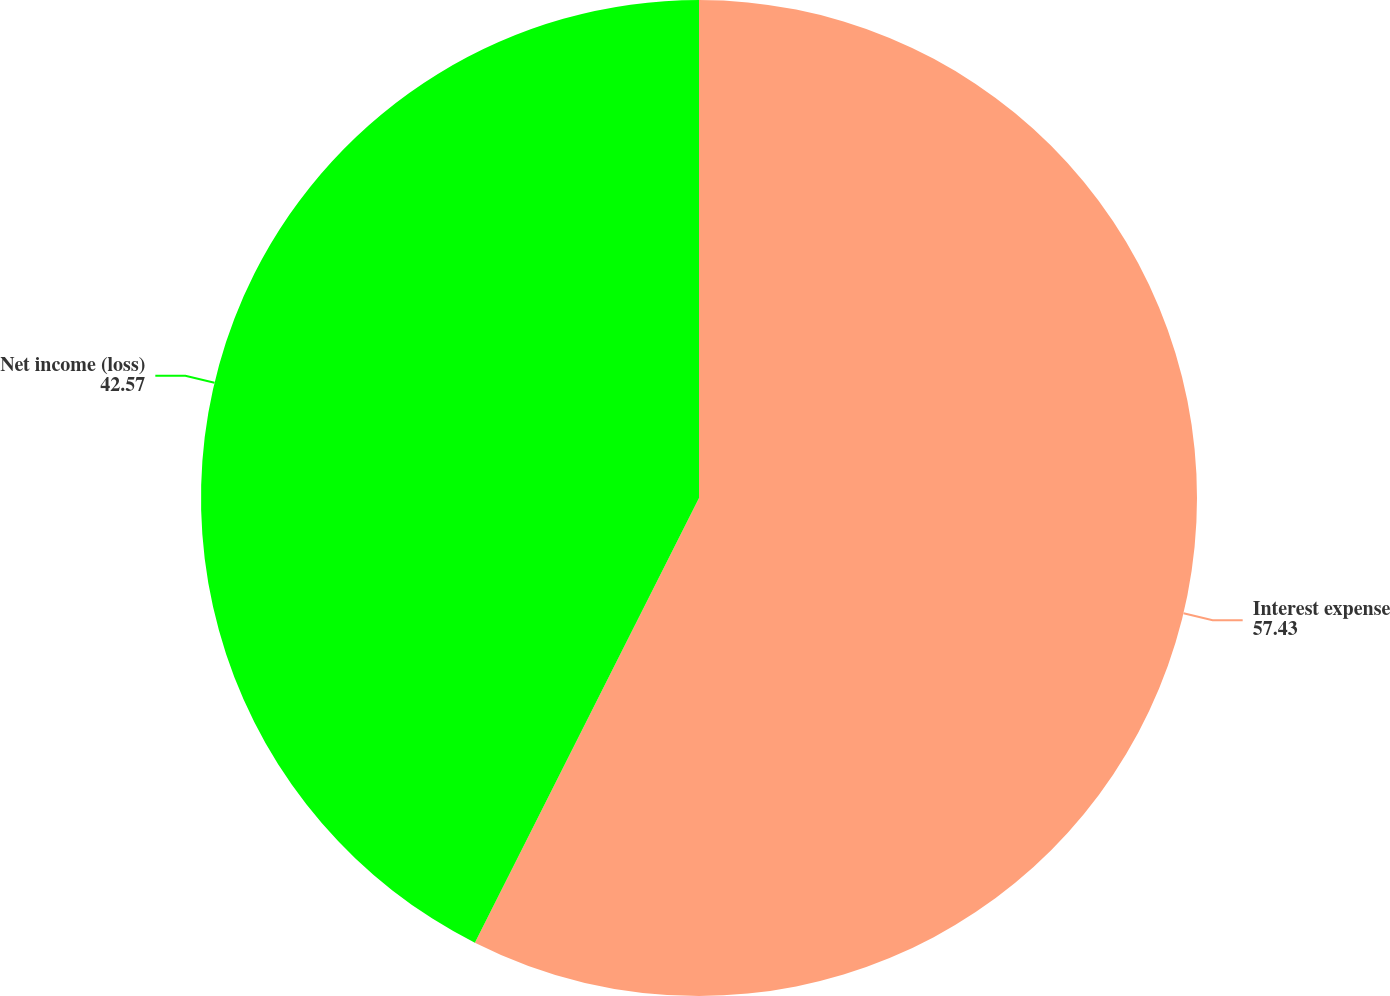<chart> <loc_0><loc_0><loc_500><loc_500><pie_chart><fcel>Interest expense<fcel>Net income (loss)<nl><fcel>57.43%<fcel>42.57%<nl></chart> 